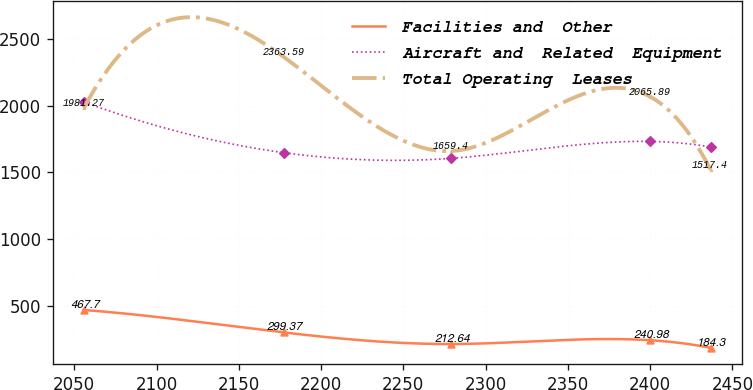<chart> <loc_0><loc_0><loc_500><loc_500><line_chart><ecel><fcel>Facilities and  Other<fcel>Aircraft and  Related  Equipment<fcel>Total Operating  Leases<nl><fcel>2055.83<fcel>467.7<fcel>2027.25<fcel>1981.27<nl><fcel>2177.41<fcel>299.37<fcel>1646.89<fcel>2363.59<nl><fcel>2279.24<fcel>212.64<fcel>1604.63<fcel>1659.4<nl><fcel>2400.16<fcel>240.98<fcel>1731.41<fcel>2065.89<nl><fcel>2436.72<fcel>184.3<fcel>1689.15<fcel>1517.4<nl></chart> 